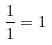<formula> <loc_0><loc_0><loc_500><loc_500>\frac { 1 } { 1 } = 1</formula> 